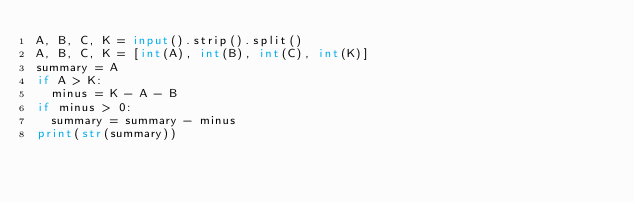Convert code to text. <code><loc_0><loc_0><loc_500><loc_500><_Python_>A, B, C, K = input().strip().split()
A, B, C, K = [int(A), int(B), int(C), int(K)]
summary = A
if A > K:
  minus = K - A - B
if minus > 0:
  summary = summary - minus
print(str(summary))</code> 